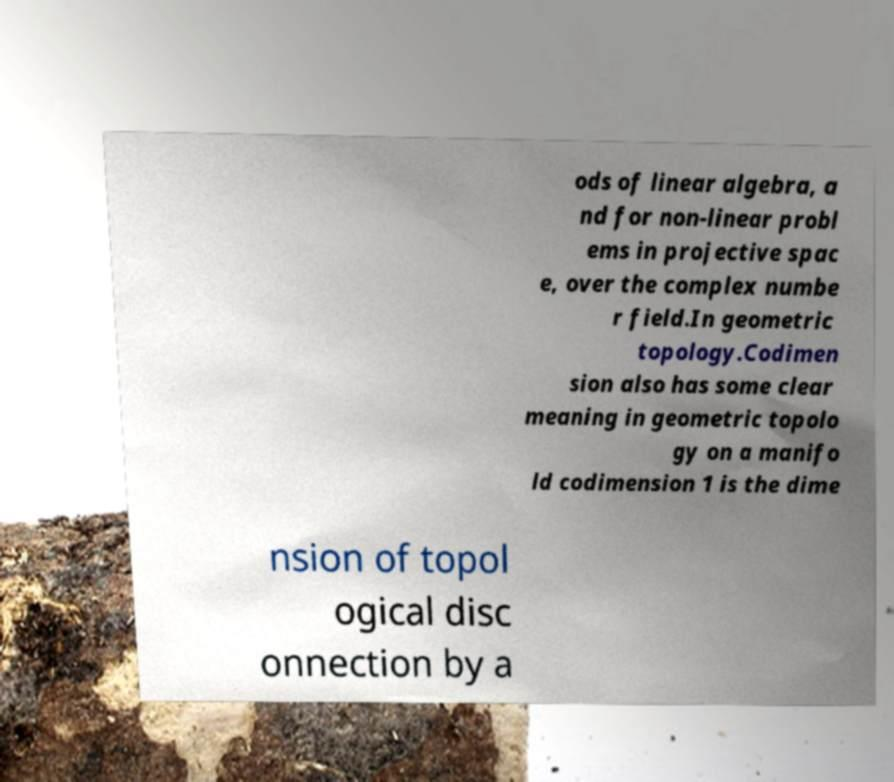Could you assist in decoding the text presented in this image and type it out clearly? ods of linear algebra, a nd for non-linear probl ems in projective spac e, over the complex numbe r field.In geometric topology.Codimen sion also has some clear meaning in geometric topolo gy on a manifo ld codimension 1 is the dime nsion of topol ogical disc onnection by a 